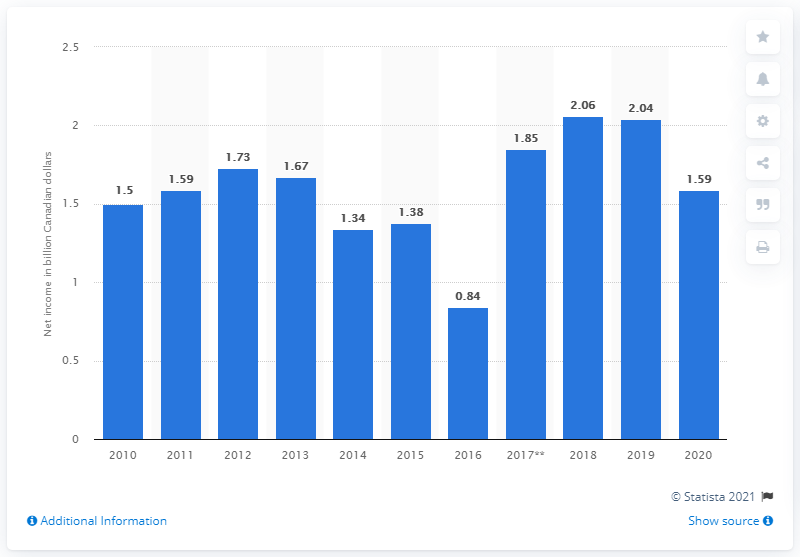Indicate a few pertinent items in this graphic. The net income of Rogers Communications for the calendar year ending December 31, 2020, was CA$1.59 billion. Rogers Communications' net income in 2019 was 2.04 million. 